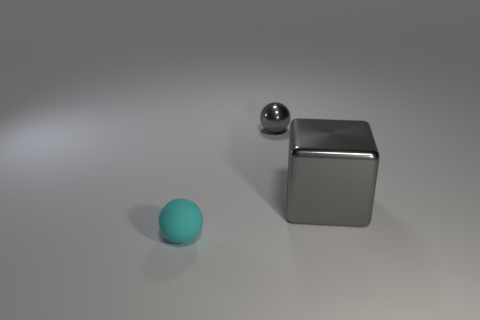Is there any other thing that has the same shape as the big gray metal thing?
Ensure brevity in your answer.  No. What is the size of the thing that is on the left side of the large shiny cube and behind the small cyan rubber object?
Keep it short and to the point. Small. What number of matte things are large gray objects or balls?
Offer a very short reply. 1. There is a thing in front of the big gray shiny thing; is its shape the same as the small object that is to the right of the cyan matte ball?
Offer a very short reply. Yes. Are there any other big gray things that have the same material as the large gray thing?
Provide a short and direct response. No. The large metallic object is what color?
Offer a terse response. Gray. There is a gray thing to the right of the gray shiny sphere; what size is it?
Keep it short and to the point. Large. What number of rubber objects are the same color as the tiny rubber ball?
Provide a succinct answer. 0. There is a ball in front of the big gray metallic object; are there any small cyan balls that are in front of it?
Your response must be concise. No. Is the color of the small thing in front of the small gray ball the same as the ball right of the rubber thing?
Provide a short and direct response. No. 